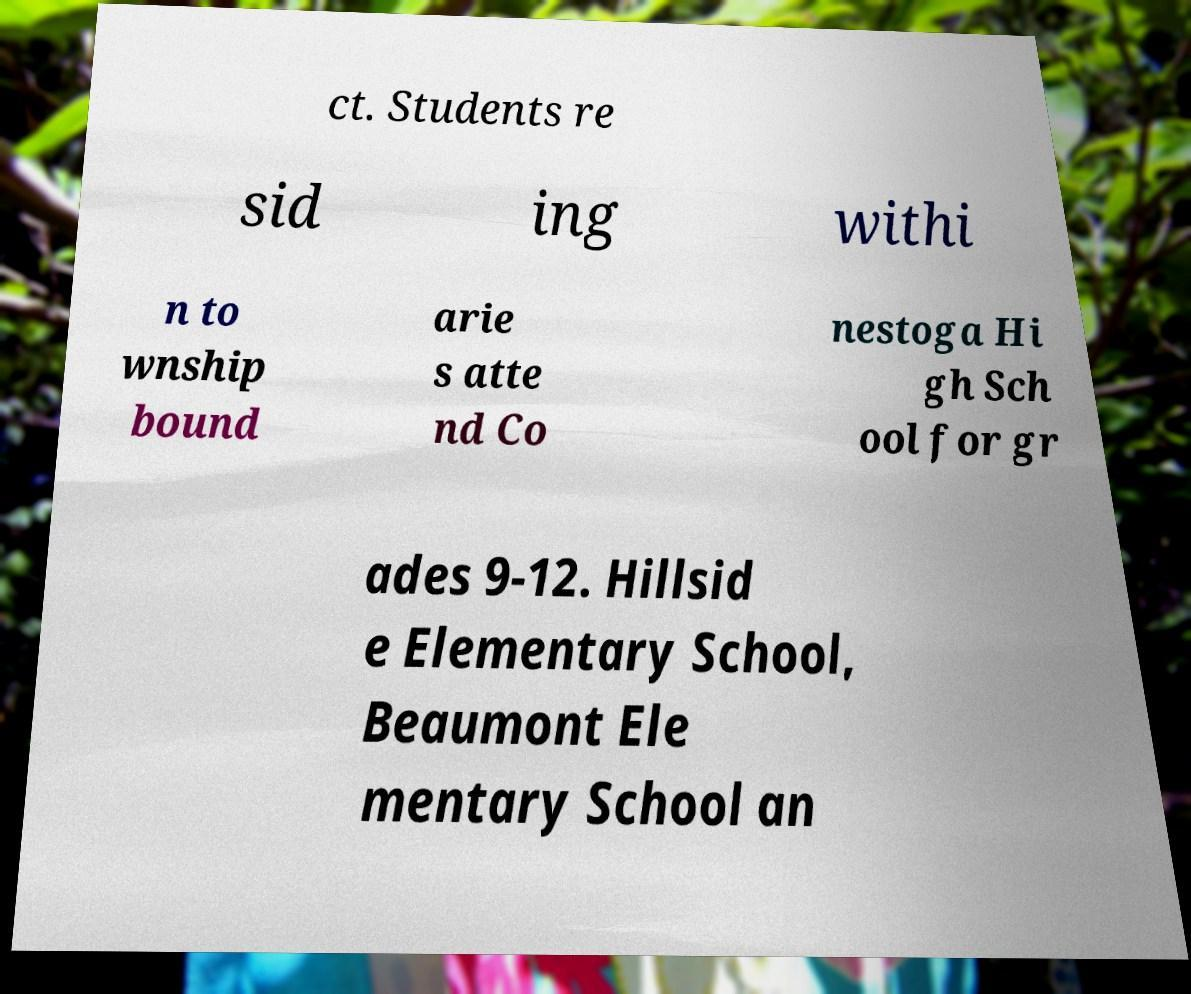Could you assist in decoding the text presented in this image and type it out clearly? ct. Students re sid ing withi n to wnship bound arie s atte nd Co nestoga Hi gh Sch ool for gr ades 9-12. Hillsid e Elementary School, Beaumont Ele mentary School an 